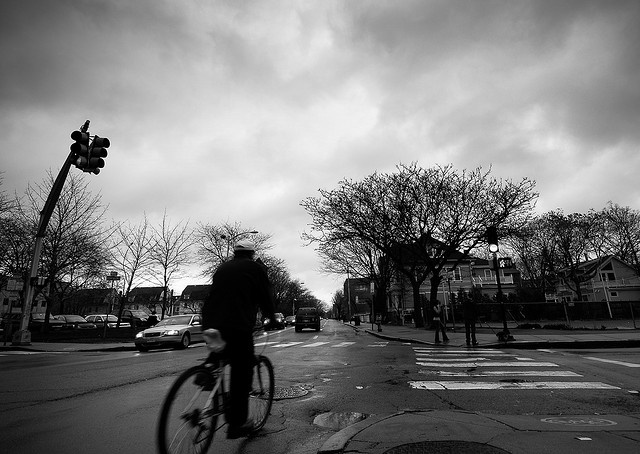Describe the objects in this image and their specific colors. I can see bicycle in black, gray, darkgray, and lightgray tones, people in black, gray, darkgray, and lightgray tones, car in black, gray, darkgray, and lightgray tones, people in black and gray tones, and truck in black, gray, and darkgray tones in this image. 